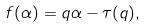Convert formula to latex. <formula><loc_0><loc_0><loc_500><loc_500>f ( \alpha ) = q \alpha - \tau ( q ) ,</formula> 